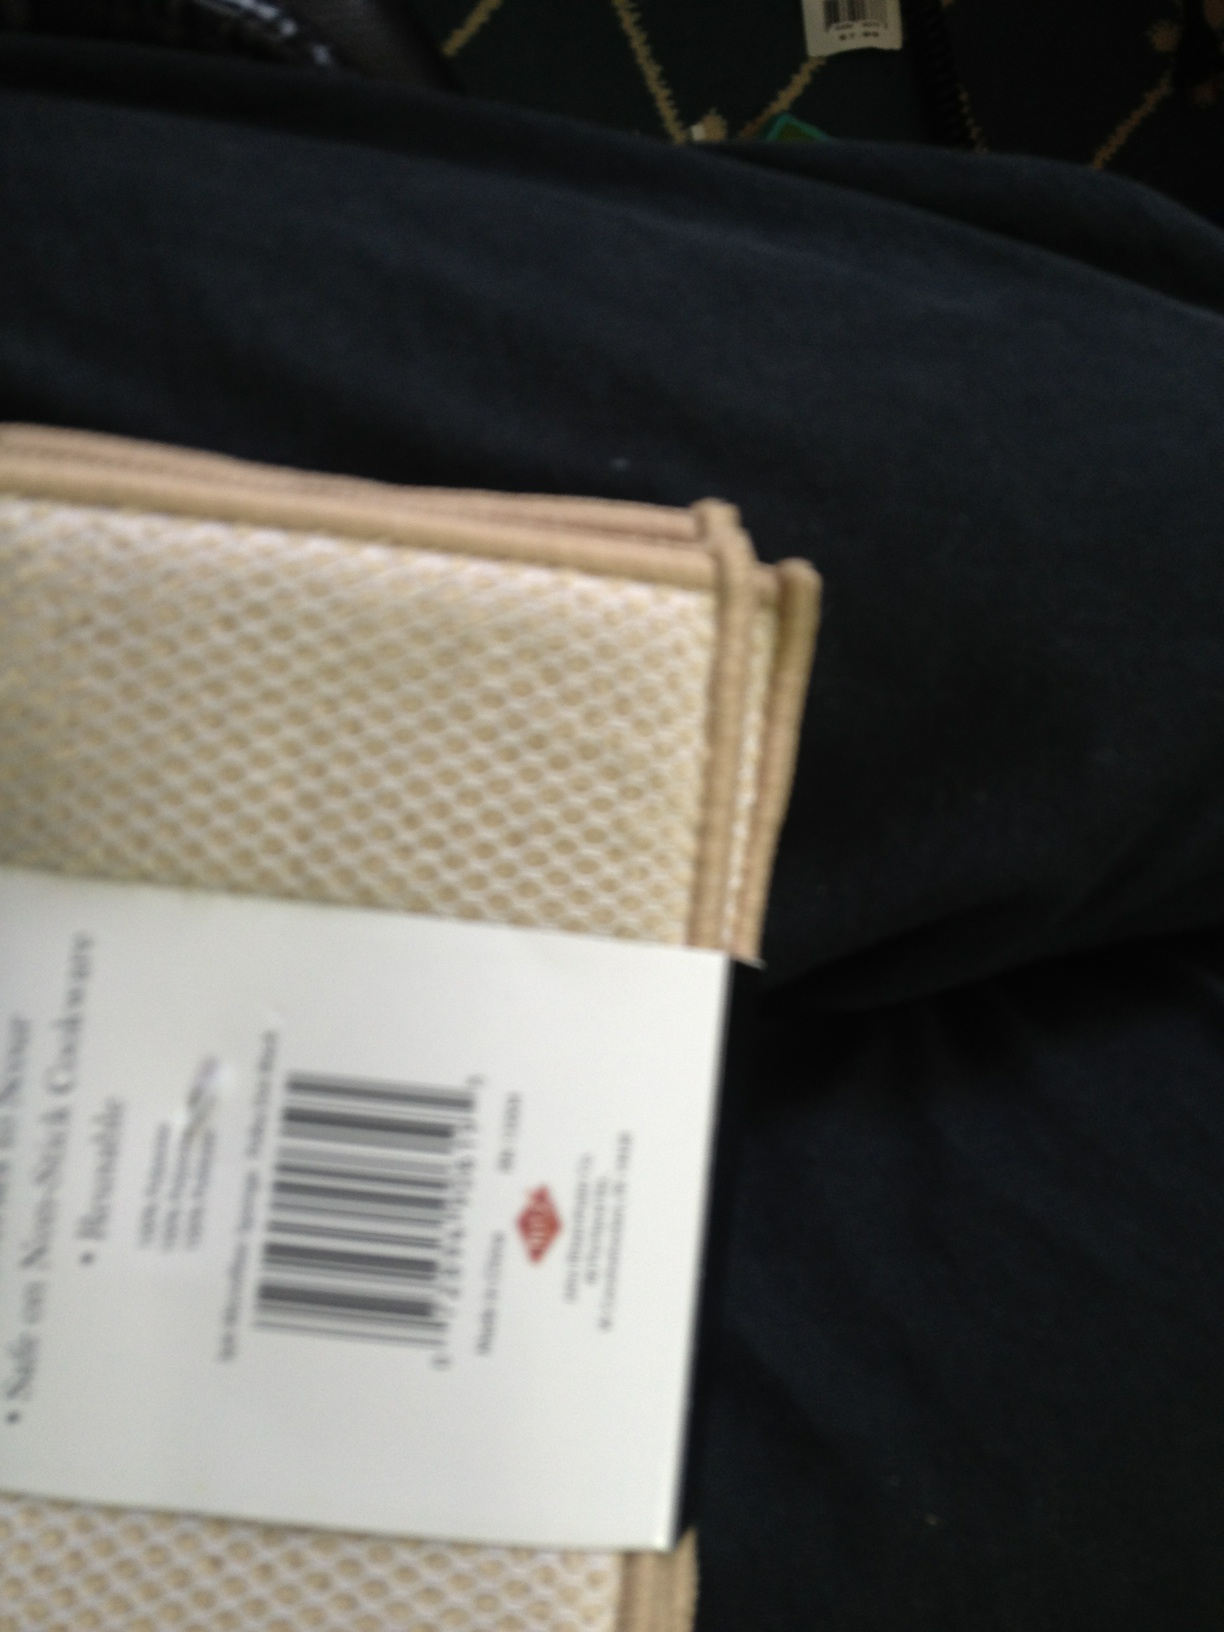Can you describe what's going on in this image? Certainly. The image is a bit out of focus and appears to be taken from a close angle, showing what seems to be a patterned beige object, possibly a wallet or some kind of holder. There's a barcode visible, suggesting it might be a new purchase. The background features a black material, perhaps pants, and a patterned green surface which could be a vehicle seat or a couch. 